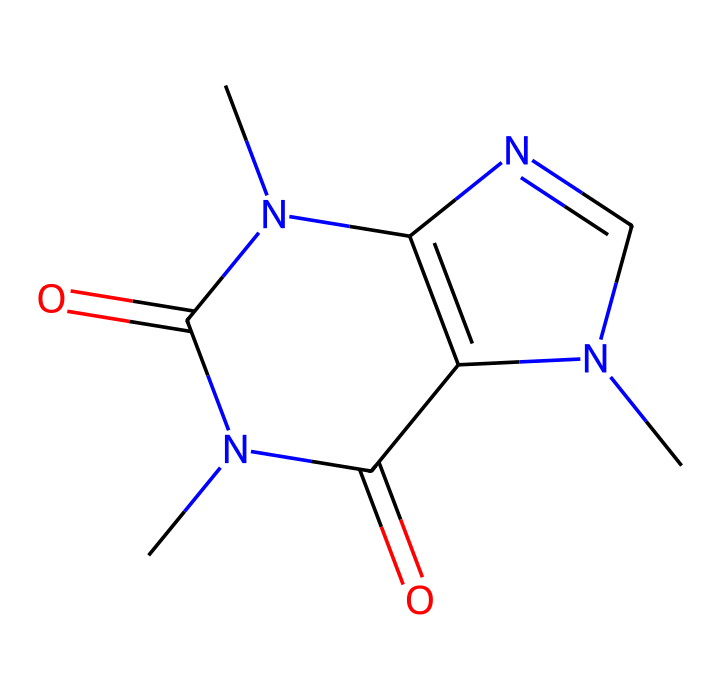How many nitrogen atoms are present in the caffeine structure? The SMILES representation CN1C=NC2=C1C(=O)N(C(=O)N2C)C indicates the presence of 'N' symbols, which represent nitrogen atoms. Counting them, we find there are four 'N's in the structure.
Answer: four What type of functional groups appear in caffeine? By examining the structure in the SMILES, we can identify amide groups (C(=O)N) due to the carbonyl (C=O) directly bonded to nitrogen (N). There are two such groups in the compound.
Answer: amide What is the total number of rings in the structure of caffeine? The depiction of the structure shows two interconnected rings based on the presence of numerical identifiers in the SMILES. Specifically, "N1" and "N2" indicate the start and end of these rings.
Answer: two Does caffeine have any aromatic rings? By looking at the structure, we can identify that the carbon-nitrogen bonds in the cyclic areas create a planar structure, which is a hallmark of aromatic compounds. The presence of carbon atoms in a cyclic structure indicates the likelihood of aromaticity.
Answer: yes Which component of caffeine contributes to its stimulatory effects? The nitrogen atoms in the cyclic structure of caffeine play a vital role in its physiological activity, notably by blocking adenosine receptors in the brain, which contributes to its stimulating effects.
Answer: nitrogen What property does caffeine exhibit due to its chemical structure? The presence of multiple nitrogen atoms and the overall structure indicates that caffeine is classified as a psychoactive compound. This classification is derived from its action on the central nervous system due to its structure.
Answer: psychoactive 